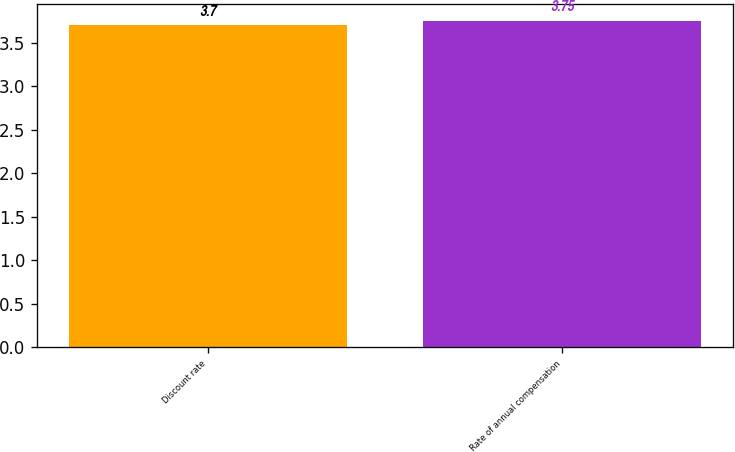Convert chart. <chart><loc_0><loc_0><loc_500><loc_500><bar_chart><fcel>Discount rate<fcel>Rate of annual compensation<nl><fcel>3.7<fcel>3.75<nl></chart> 